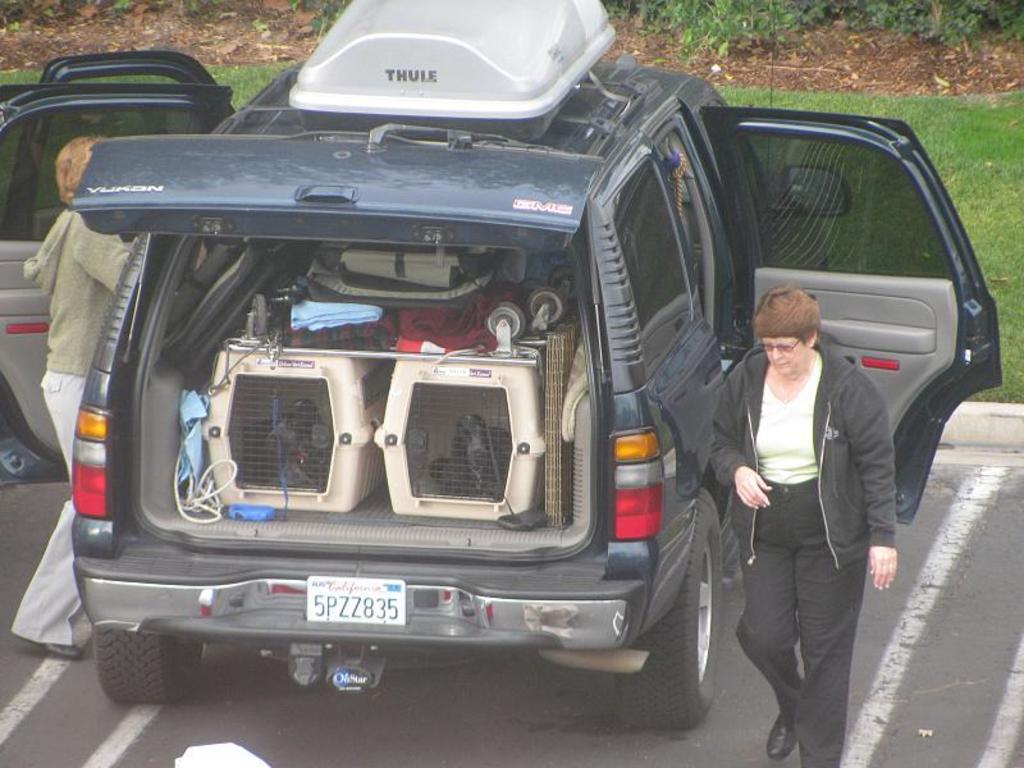In one or two sentences, can you explain what this image depicts? In this image we can see a car which is placed on the road and two people standing beside it. We can also see some clothes, wire, a mat and containers in a boot of a car. On the backside we can see some grass and the plants. 